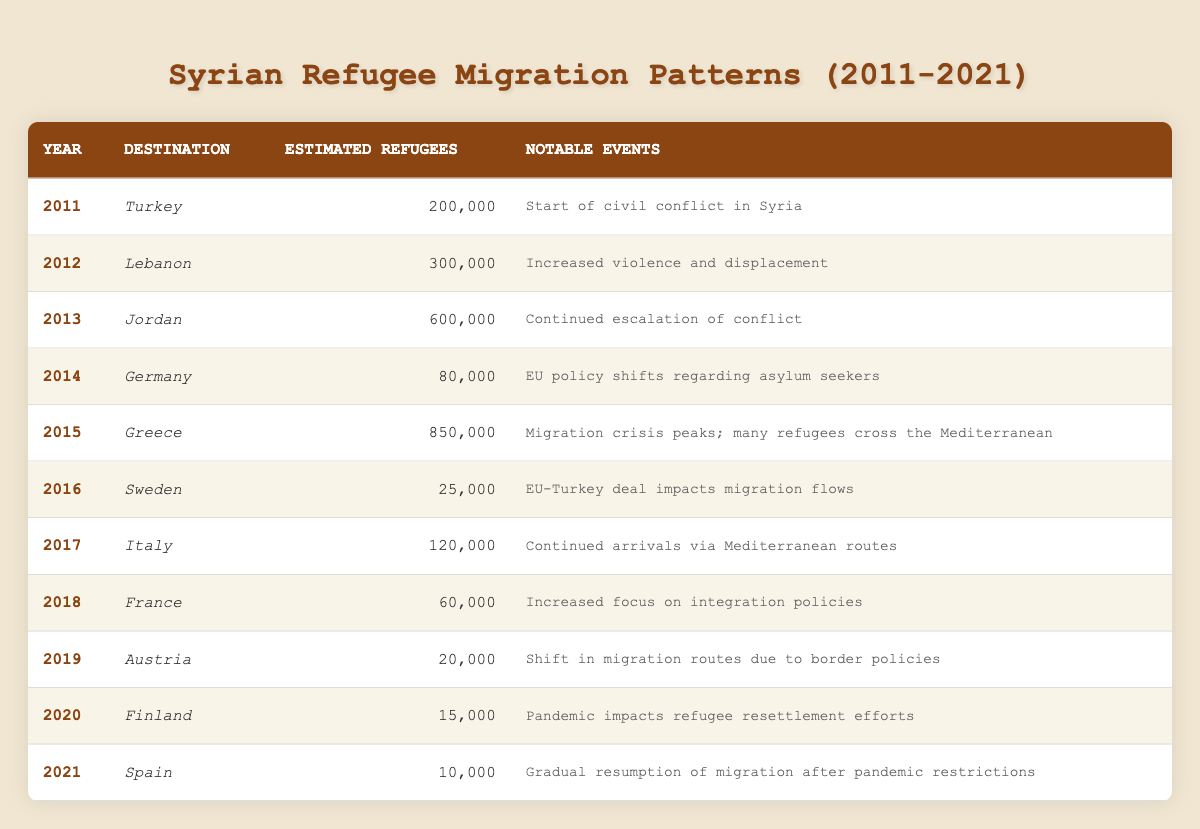What was the estimated number of refugees from Syria to Germany in 2014? The table indicates that in 2014, Germany received an estimated 80,000 refugees from Syria. This value is directly mentioned in the row corresponding to the year 2014.
Answer: 80,000 Which country received the highest number of Syrian refugees in 2015? According to the table, Greece received the highest number of Syrian refugees in 2015, with an estimated 850,000 refugees, as reported in the 2015 row of the table.
Answer: Greece What was the total estimated number of refugees from Syria to Turkey and Lebanon combined in 2011 and 2012? Referring to the table, in 2011, Turkey received 200,000 refugees and in 2012, Lebanon received 300,000 refugees. Adding these two values gives a total of 200,000 + 300,000 = 500,000.
Answer: 500,000 Did Syria's civil conflict begin in 2011 according to the table? The table states that in 2011, there was a notable event marked as "Start of civil conflict in Syria," which confirms that the civil conflict did indeed begin in that year.
Answer: Yes Which year had the lowest estimated number of refugees and what was that number? By examining the table, we can note that 2021 had the lowest estimated number of refugees, with only 10,000 reported. This can be identified by comparing all refugee numbers in each year.
Answer: 10,000 